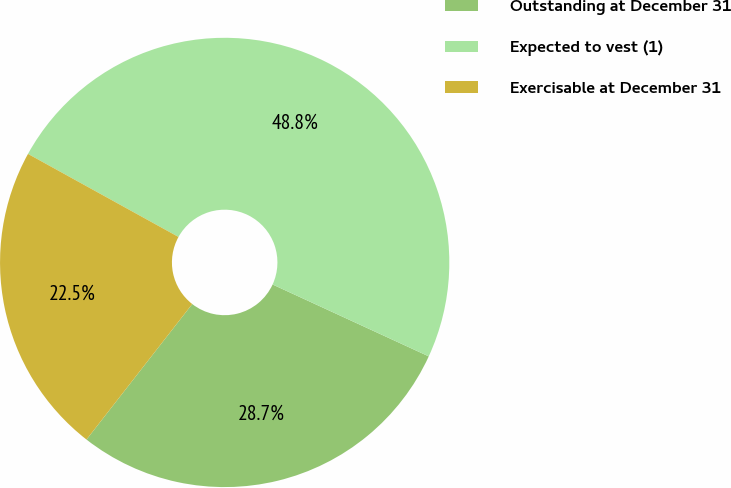<chart> <loc_0><loc_0><loc_500><loc_500><pie_chart><fcel>Outstanding at December 31<fcel>Expected to vest (1)<fcel>Exercisable at December 31<nl><fcel>28.68%<fcel>48.84%<fcel>22.48%<nl></chart> 